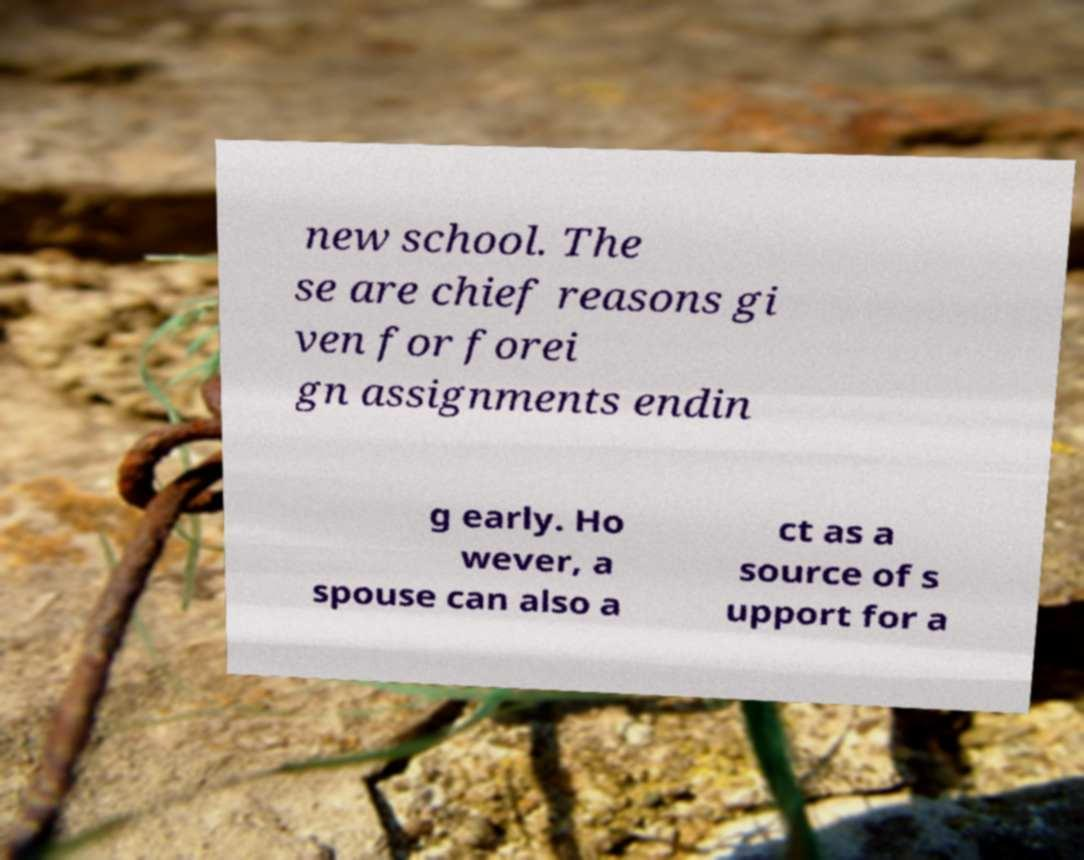Please identify and transcribe the text found in this image. new school. The se are chief reasons gi ven for forei gn assignments endin g early. Ho wever, a spouse can also a ct as a source of s upport for a 